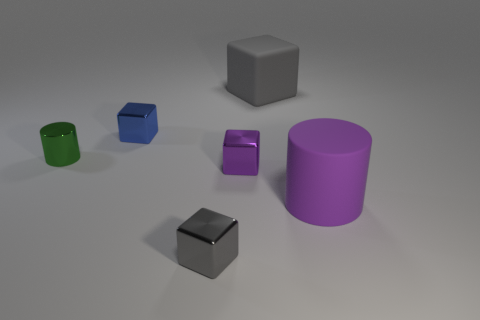There is a cylinder left of the rubber thing behind the big matte object in front of the green shiny object; what color is it?
Your answer should be very brief. Green. There is a large rubber object that is behind the large rubber cylinder; what shape is it?
Your response must be concise. Cube. There is a purple thing that is the same material as the blue object; what is its shape?
Your answer should be compact. Cube. There is a large gray rubber block; what number of objects are right of it?
Offer a terse response. 1. Are there the same number of big objects that are in front of the large gray rubber cube and large cylinders?
Make the answer very short. Yes. Is the material of the tiny gray cube the same as the blue cube?
Make the answer very short. Yes. There is a thing that is to the right of the small purple metallic cube and behind the green thing; what size is it?
Your response must be concise. Large. What number of metal cylinders are the same size as the purple metallic thing?
Your answer should be very brief. 1. There is a shiny cube that is on the right side of the small metallic thing that is in front of the large purple thing; what size is it?
Offer a very short reply. Small. There is a tiny thing that is on the right side of the tiny gray shiny object; is its shape the same as the big object behind the green metal thing?
Your answer should be very brief. Yes. 